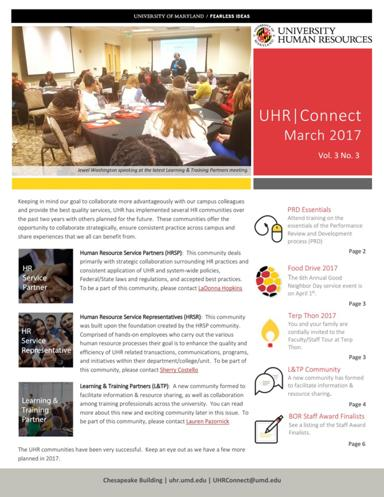What are some of the contents mentioned in the text? The contents detailed in the UHR Connect newsletter include notable sections like PRD Essentials - guiding staff through performance review documentation, promotions surrounding the annual food drive and Terp Thon 2017 events, updates on staff development opportunities, and recognition of staff achievements such as the 3OR Staff Award Finalists. This mix of content showcases their active engagement in enhancing work culture and staff welfare at the university. 